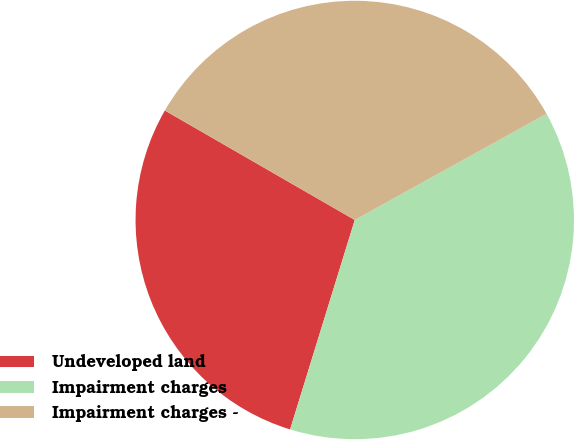Convert chart. <chart><loc_0><loc_0><loc_500><loc_500><pie_chart><fcel>Undeveloped land<fcel>Impairment charges<fcel>Impairment charges -<nl><fcel>28.56%<fcel>37.82%<fcel>33.63%<nl></chart> 